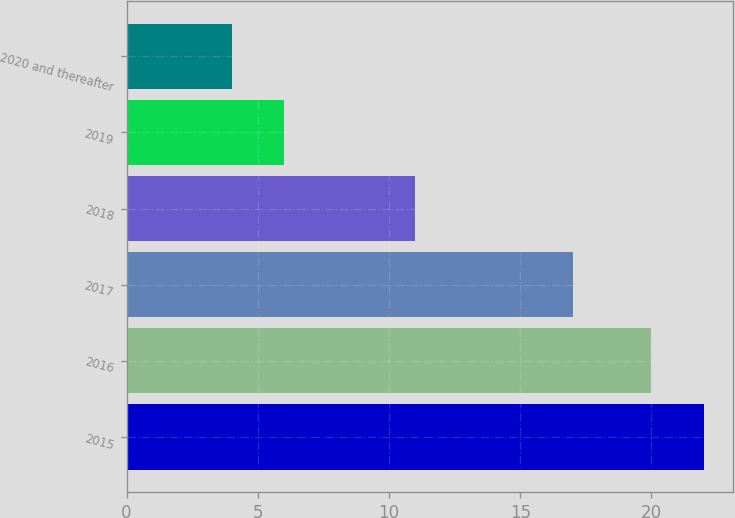Convert chart. <chart><loc_0><loc_0><loc_500><loc_500><bar_chart><fcel>2015<fcel>2016<fcel>2017<fcel>2018<fcel>2019<fcel>2020 and thereafter<nl><fcel>22<fcel>20<fcel>17<fcel>11<fcel>6<fcel>4<nl></chart> 